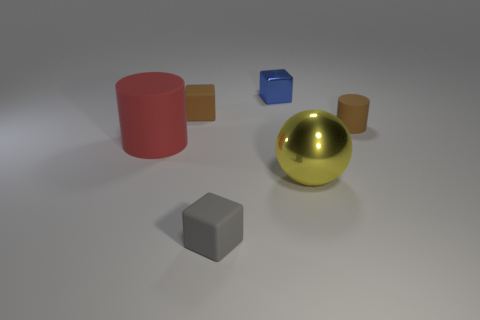The other rubber thing that is the same shape as the big red thing is what size? The small blue cube appears to be a miniature version of the larger red cylinder, likely a third of its size in volume, making it small in comparison. 